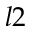<formula> <loc_0><loc_0><loc_500><loc_500>l 2</formula> 